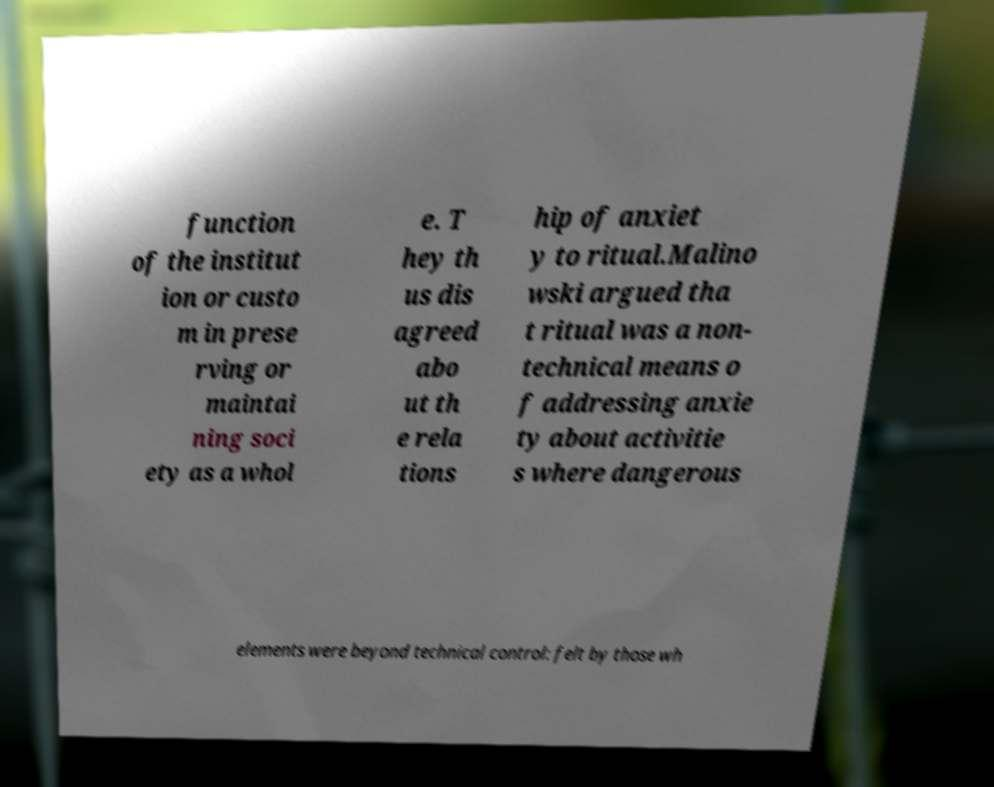Please identify and transcribe the text found in this image. function of the institut ion or custo m in prese rving or maintai ning soci ety as a whol e. T hey th us dis agreed abo ut th e rela tions hip of anxiet y to ritual.Malino wski argued tha t ritual was a non- technical means o f addressing anxie ty about activitie s where dangerous elements were beyond technical control: felt by those wh 